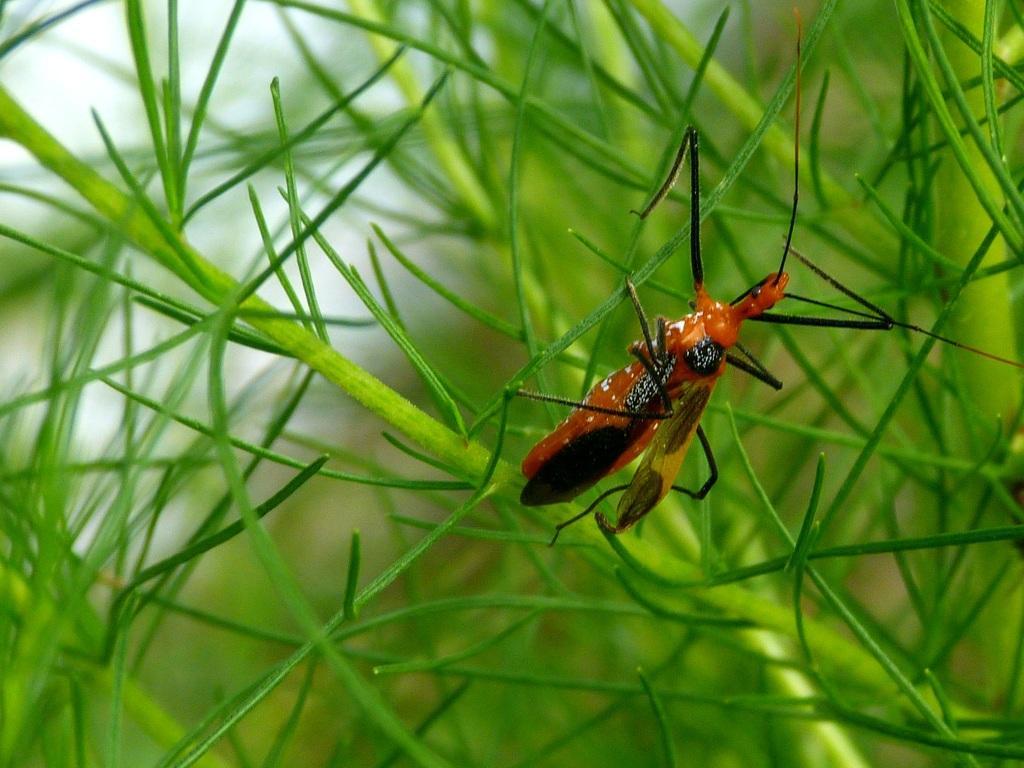Can you describe this image briefly? In this image, we can see an insect and in the background, there are plants. 